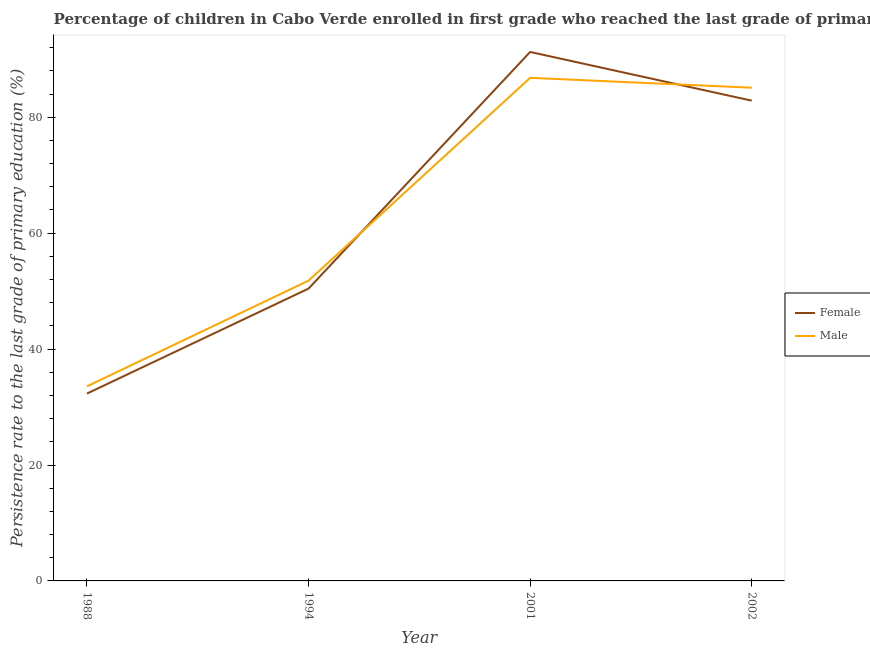How many different coloured lines are there?
Make the answer very short. 2. Does the line corresponding to persistence rate of male students intersect with the line corresponding to persistence rate of female students?
Your answer should be compact. Yes. Is the number of lines equal to the number of legend labels?
Offer a very short reply. Yes. What is the persistence rate of female students in 2002?
Make the answer very short. 82.87. Across all years, what is the maximum persistence rate of male students?
Your answer should be very brief. 86.81. Across all years, what is the minimum persistence rate of female students?
Provide a short and direct response. 32.32. In which year was the persistence rate of female students maximum?
Offer a very short reply. 2001. In which year was the persistence rate of female students minimum?
Ensure brevity in your answer.  1988. What is the total persistence rate of female students in the graph?
Keep it short and to the point. 256.9. What is the difference between the persistence rate of female students in 1994 and that in 2002?
Your response must be concise. -32.43. What is the difference between the persistence rate of female students in 1994 and the persistence rate of male students in 2002?
Offer a very short reply. -34.66. What is the average persistence rate of female students per year?
Your answer should be compact. 64.22. In the year 2002, what is the difference between the persistence rate of female students and persistence rate of male students?
Give a very brief answer. -2.23. What is the ratio of the persistence rate of female students in 1994 to that in 2002?
Provide a succinct answer. 0.61. Is the persistence rate of male students in 2001 less than that in 2002?
Make the answer very short. No. What is the difference between the highest and the second highest persistence rate of female students?
Ensure brevity in your answer.  8.4. What is the difference between the highest and the lowest persistence rate of female students?
Provide a succinct answer. 58.94. Is the persistence rate of male students strictly greater than the persistence rate of female students over the years?
Make the answer very short. No. Is the persistence rate of female students strictly less than the persistence rate of male students over the years?
Make the answer very short. No. What is the difference between two consecutive major ticks on the Y-axis?
Your answer should be very brief. 20. Does the graph contain grids?
Ensure brevity in your answer.  No. How many legend labels are there?
Provide a succinct answer. 2. How are the legend labels stacked?
Give a very brief answer. Vertical. What is the title of the graph?
Offer a very short reply. Percentage of children in Cabo Verde enrolled in first grade who reached the last grade of primary education. What is the label or title of the X-axis?
Give a very brief answer. Year. What is the label or title of the Y-axis?
Provide a short and direct response. Persistence rate to the last grade of primary education (%). What is the Persistence rate to the last grade of primary education (%) of Female in 1988?
Offer a terse response. 32.32. What is the Persistence rate to the last grade of primary education (%) in Male in 1988?
Your answer should be compact. 33.57. What is the Persistence rate to the last grade of primary education (%) in Female in 1994?
Your answer should be very brief. 50.44. What is the Persistence rate to the last grade of primary education (%) in Male in 1994?
Ensure brevity in your answer.  51.81. What is the Persistence rate to the last grade of primary education (%) of Female in 2001?
Provide a short and direct response. 91.27. What is the Persistence rate to the last grade of primary education (%) of Male in 2001?
Provide a succinct answer. 86.81. What is the Persistence rate to the last grade of primary education (%) of Female in 2002?
Make the answer very short. 82.87. What is the Persistence rate to the last grade of primary education (%) in Male in 2002?
Your answer should be compact. 85.1. Across all years, what is the maximum Persistence rate to the last grade of primary education (%) in Female?
Offer a very short reply. 91.27. Across all years, what is the maximum Persistence rate to the last grade of primary education (%) in Male?
Your answer should be very brief. 86.81. Across all years, what is the minimum Persistence rate to the last grade of primary education (%) in Female?
Give a very brief answer. 32.32. Across all years, what is the minimum Persistence rate to the last grade of primary education (%) in Male?
Offer a very short reply. 33.57. What is the total Persistence rate to the last grade of primary education (%) in Female in the graph?
Provide a succinct answer. 256.9. What is the total Persistence rate to the last grade of primary education (%) of Male in the graph?
Provide a short and direct response. 257.29. What is the difference between the Persistence rate to the last grade of primary education (%) in Female in 1988 and that in 1994?
Your answer should be compact. -18.12. What is the difference between the Persistence rate to the last grade of primary education (%) in Male in 1988 and that in 1994?
Ensure brevity in your answer.  -18.24. What is the difference between the Persistence rate to the last grade of primary education (%) in Female in 1988 and that in 2001?
Your answer should be compact. -58.94. What is the difference between the Persistence rate to the last grade of primary education (%) of Male in 1988 and that in 2001?
Give a very brief answer. -53.23. What is the difference between the Persistence rate to the last grade of primary education (%) of Female in 1988 and that in 2002?
Make the answer very short. -50.54. What is the difference between the Persistence rate to the last grade of primary education (%) of Male in 1988 and that in 2002?
Your answer should be very brief. -51.53. What is the difference between the Persistence rate to the last grade of primary education (%) in Female in 1994 and that in 2001?
Provide a short and direct response. -40.83. What is the difference between the Persistence rate to the last grade of primary education (%) in Male in 1994 and that in 2001?
Offer a very short reply. -34.99. What is the difference between the Persistence rate to the last grade of primary education (%) of Female in 1994 and that in 2002?
Your response must be concise. -32.43. What is the difference between the Persistence rate to the last grade of primary education (%) of Male in 1994 and that in 2002?
Provide a succinct answer. -33.29. What is the difference between the Persistence rate to the last grade of primary education (%) in Female in 2001 and that in 2002?
Make the answer very short. 8.4. What is the difference between the Persistence rate to the last grade of primary education (%) in Male in 2001 and that in 2002?
Your answer should be compact. 1.7. What is the difference between the Persistence rate to the last grade of primary education (%) of Female in 1988 and the Persistence rate to the last grade of primary education (%) of Male in 1994?
Provide a succinct answer. -19.49. What is the difference between the Persistence rate to the last grade of primary education (%) in Female in 1988 and the Persistence rate to the last grade of primary education (%) in Male in 2001?
Provide a succinct answer. -54.48. What is the difference between the Persistence rate to the last grade of primary education (%) in Female in 1988 and the Persistence rate to the last grade of primary education (%) in Male in 2002?
Offer a terse response. -52.78. What is the difference between the Persistence rate to the last grade of primary education (%) of Female in 1994 and the Persistence rate to the last grade of primary education (%) of Male in 2001?
Your answer should be compact. -36.37. What is the difference between the Persistence rate to the last grade of primary education (%) of Female in 1994 and the Persistence rate to the last grade of primary education (%) of Male in 2002?
Your answer should be very brief. -34.66. What is the difference between the Persistence rate to the last grade of primary education (%) in Female in 2001 and the Persistence rate to the last grade of primary education (%) in Male in 2002?
Keep it short and to the point. 6.17. What is the average Persistence rate to the last grade of primary education (%) of Female per year?
Give a very brief answer. 64.22. What is the average Persistence rate to the last grade of primary education (%) in Male per year?
Ensure brevity in your answer.  64.32. In the year 1988, what is the difference between the Persistence rate to the last grade of primary education (%) in Female and Persistence rate to the last grade of primary education (%) in Male?
Offer a terse response. -1.25. In the year 1994, what is the difference between the Persistence rate to the last grade of primary education (%) of Female and Persistence rate to the last grade of primary education (%) of Male?
Ensure brevity in your answer.  -1.37. In the year 2001, what is the difference between the Persistence rate to the last grade of primary education (%) of Female and Persistence rate to the last grade of primary education (%) of Male?
Provide a succinct answer. 4.46. In the year 2002, what is the difference between the Persistence rate to the last grade of primary education (%) of Female and Persistence rate to the last grade of primary education (%) of Male?
Make the answer very short. -2.23. What is the ratio of the Persistence rate to the last grade of primary education (%) of Female in 1988 to that in 1994?
Your response must be concise. 0.64. What is the ratio of the Persistence rate to the last grade of primary education (%) of Male in 1988 to that in 1994?
Provide a short and direct response. 0.65. What is the ratio of the Persistence rate to the last grade of primary education (%) of Female in 1988 to that in 2001?
Provide a succinct answer. 0.35. What is the ratio of the Persistence rate to the last grade of primary education (%) in Male in 1988 to that in 2001?
Your answer should be very brief. 0.39. What is the ratio of the Persistence rate to the last grade of primary education (%) in Female in 1988 to that in 2002?
Your answer should be compact. 0.39. What is the ratio of the Persistence rate to the last grade of primary education (%) of Male in 1988 to that in 2002?
Your answer should be very brief. 0.39. What is the ratio of the Persistence rate to the last grade of primary education (%) of Female in 1994 to that in 2001?
Provide a short and direct response. 0.55. What is the ratio of the Persistence rate to the last grade of primary education (%) of Male in 1994 to that in 2001?
Offer a very short reply. 0.6. What is the ratio of the Persistence rate to the last grade of primary education (%) of Female in 1994 to that in 2002?
Provide a succinct answer. 0.61. What is the ratio of the Persistence rate to the last grade of primary education (%) in Male in 1994 to that in 2002?
Your answer should be compact. 0.61. What is the ratio of the Persistence rate to the last grade of primary education (%) in Female in 2001 to that in 2002?
Offer a terse response. 1.1. What is the ratio of the Persistence rate to the last grade of primary education (%) of Male in 2001 to that in 2002?
Give a very brief answer. 1.02. What is the difference between the highest and the second highest Persistence rate to the last grade of primary education (%) in Female?
Your answer should be very brief. 8.4. What is the difference between the highest and the second highest Persistence rate to the last grade of primary education (%) of Male?
Offer a very short reply. 1.7. What is the difference between the highest and the lowest Persistence rate to the last grade of primary education (%) in Female?
Make the answer very short. 58.94. What is the difference between the highest and the lowest Persistence rate to the last grade of primary education (%) of Male?
Provide a short and direct response. 53.23. 